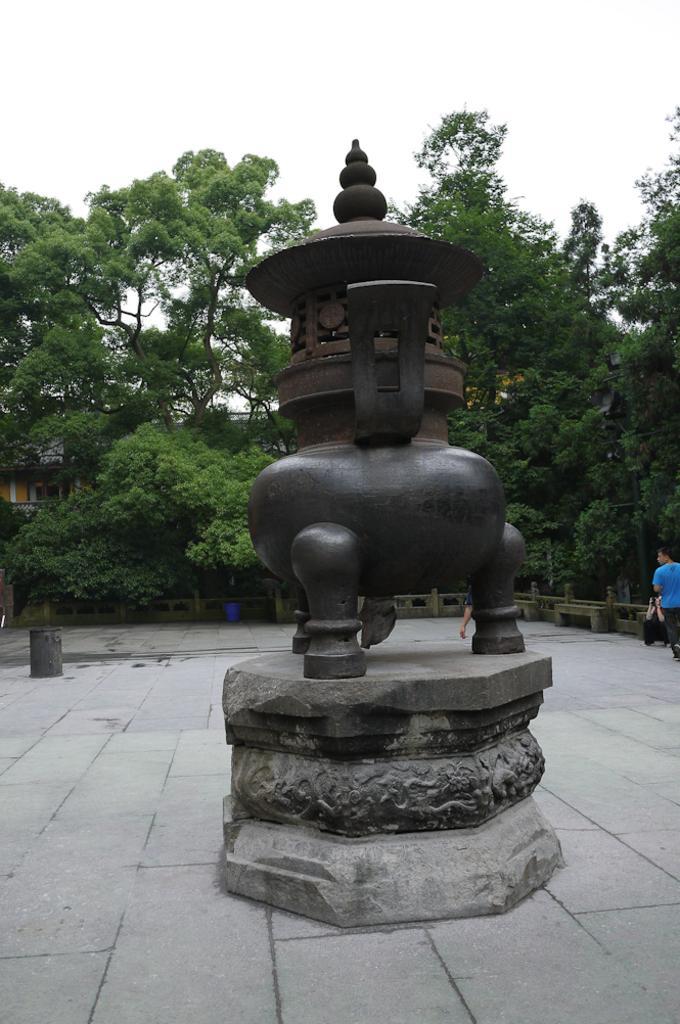How would you summarize this image in a sentence or two? In this image I can see a statue which is black in color, the floor and a person wearing blue colored dress is stunning. I can see few trees which are green in color, a building and the sky. 